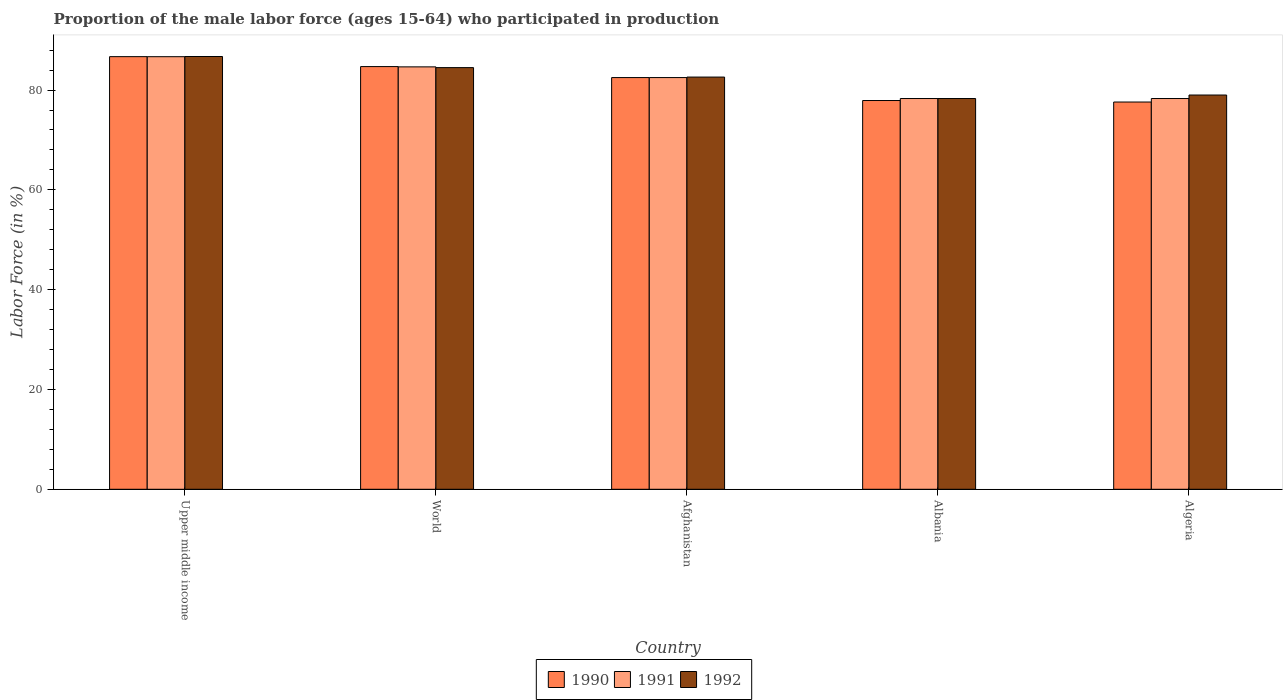How many groups of bars are there?
Your response must be concise. 5. Are the number of bars per tick equal to the number of legend labels?
Your answer should be compact. Yes. How many bars are there on the 4th tick from the left?
Your answer should be very brief. 3. How many bars are there on the 1st tick from the right?
Make the answer very short. 3. What is the label of the 5th group of bars from the left?
Offer a very short reply. Algeria. What is the proportion of the male labor force who participated in production in 1991 in Afghanistan?
Your answer should be very brief. 82.5. Across all countries, what is the maximum proportion of the male labor force who participated in production in 1992?
Keep it short and to the point. 86.72. Across all countries, what is the minimum proportion of the male labor force who participated in production in 1990?
Offer a very short reply. 77.6. In which country was the proportion of the male labor force who participated in production in 1990 maximum?
Ensure brevity in your answer.  Upper middle income. In which country was the proportion of the male labor force who participated in production in 1990 minimum?
Ensure brevity in your answer.  Algeria. What is the total proportion of the male labor force who participated in production in 1990 in the graph?
Offer a very short reply. 409.39. What is the difference between the proportion of the male labor force who participated in production in 1992 in Afghanistan and that in World?
Keep it short and to the point. -1.89. What is the difference between the proportion of the male labor force who participated in production in 1992 in World and the proportion of the male labor force who participated in production in 1991 in Algeria?
Provide a short and direct response. 6.19. What is the average proportion of the male labor force who participated in production in 1990 per country?
Make the answer very short. 81.88. What is the difference between the proportion of the male labor force who participated in production of/in 1990 and proportion of the male labor force who participated in production of/in 1992 in World?
Offer a terse response. 0.2. What is the ratio of the proportion of the male labor force who participated in production in 1991 in Afghanistan to that in Algeria?
Offer a terse response. 1.05. Is the proportion of the male labor force who participated in production in 1992 in Albania less than that in Algeria?
Your answer should be very brief. Yes. Is the difference between the proportion of the male labor force who participated in production in 1990 in Albania and World greater than the difference between the proportion of the male labor force who participated in production in 1992 in Albania and World?
Offer a very short reply. No. What is the difference between the highest and the second highest proportion of the male labor force who participated in production in 1990?
Your answer should be very brief. -2.2. What is the difference between the highest and the lowest proportion of the male labor force who participated in production in 1990?
Offer a terse response. 9.09. What does the 1st bar from the left in Afghanistan represents?
Your answer should be compact. 1990. What does the 1st bar from the right in Upper middle income represents?
Ensure brevity in your answer.  1992. How many bars are there?
Keep it short and to the point. 15. Are all the bars in the graph horizontal?
Ensure brevity in your answer.  No. Are the values on the major ticks of Y-axis written in scientific E-notation?
Your response must be concise. No. Does the graph contain any zero values?
Keep it short and to the point. No. How many legend labels are there?
Your response must be concise. 3. How are the legend labels stacked?
Make the answer very short. Horizontal. What is the title of the graph?
Provide a succinct answer. Proportion of the male labor force (ages 15-64) who participated in production. Does "1998" appear as one of the legend labels in the graph?
Your answer should be very brief. No. What is the Labor Force (in %) of 1990 in Upper middle income?
Give a very brief answer. 86.69. What is the Labor Force (in %) of 1991 in Upper middle income?
Give a very brief answer. 86.68. What is the Labor Force (in %) in 1992 in Upper middle income?
Ensure brevity in your answer.  86.72. What is the Labor Force (in %) in 1990 in World?
Your answer should be compact. 84.7. What is the Labor Force (in %) of 1991 in World?
Offer a terse response. 84.64. What is the Labor Force (in %) in 1992 in World?
Your answer should be very brief. 84.49. What is the Labor Force (in %) of 1990 in Afghanistan?
Your answer should be compact. 82.5. What is the Labor Force (in %) of 1991 in Afghanistan?
Your response must be concise. 82.5. What is the Labor Force (in %) of 1992 in Afghanistan?
Make the answer very short. 82.6. What is the Labor Force (in %) of 1990 in Albania?
Offer a terse response. 77.9. What is the Labor Force (in %) of 1991 in Albania?
Offer a terse response. 78.3. What is the Labor Force (in %) of 1992 in Albania?
Offer a terse response. 78.3. What is the Labor Force (in %) of 1990 in Algeria?
Your answer should be very brief. 77.6. What is the Labor Force (in %) of 1991 in Algeria?
Keep it short and to the point. 78.3. What is the Labor Force (in %) of 1992 in Algeria?
Your response must be concise. 79. Across all countries, what is the maximum Labor Force (in %) in 1990?
Make the answer very short. 86.69. Across all countries, what is the maximum Labor Force (in %) of 1991?
Offer a terse response. 86.68. Across all countries, what is the maximum Labor Force (in %) in 1992?
Ensure brevity in your answer.  86.72. Across all countries, what is the minimum Labor Force (in %) in 1990?
Offer a terse response. 77.6. Across all countries, what is the minimum Labor Force (in %) of 1991?
Provide a short and direct response. 78.3. Across all countries, what is the minimum Labor Force (in %) in 1992?
Make the answer very short. 78.3. What is the total Labor Force (in %) of 1990 in the graph?
Ensure brevity in your answer.  409.39. What is the total Labor Force (in %) of 1991 in the graph?
Provide a short and direct response. 410.42. What is the total Labor Force (in %) in 1992 in the graph?
Offer a terse response. 411.11. What is the difference between the Labor Force (in %) of 1990 in Upper middle income and that in World?
Keep it short and to the point. 1.99. What is the difference between the Labor Force (in %) of 1991 in Upper middle income and that in World?
Your response must be concise. 2.04. What is the difference between the Labor Force (in %) of 1992 in Upper middle income and that in World?
Your response must be concise. 2.22. What is the difference between the Labor Force (in %) in 1990 in Upper middle income and that in Afghanistan?
Provide a short and direct response. 4.19. What is the difference between the Labor Force (in %) of 1991 in Upper middle income and that in Afghanistan?
Provide a succinct answer. 4.18. What is the difference between the Labor Force (in %) of 1992 in Upper middle income and that in Afghanistan?
Offer a terse response. 4.12. What is the difference between the Labor Force (in %) in 1990 in Upper middle income and that in Albania?
Ensure brevity in your answer.  8.79. What is the difference between the Labor Force (in %) of 1991 in Upper middle income and that in Albania?
Keep it short and to the point. 8.38. What is the difference between the Labor Force (in %) in 1992 in Upper middle income and that in Albania?
Offer a terse response. 8.42. What is the difference between the Labor Force (in %) of 1990 in Upper middle income and that in Algeria?
Provide a succinct answer. 9.09. What is the difference between the Labor Force (in %) in 1991 in Upper middle income and that in Algeria?
Your response must be concise. 8.38. What is the difference between the Labor Force (in %) of 1992 in Upper middle income and that in Algeria?
Your response must be concise. 7.72. What is the difference between the Labor Force (in %) in 1990 in World and that in Afghanistan?
Make the answer very short. 2.2. What is the difference between the Labor Force (in %) of 1991 in World and that in Afghanistan?
Ensure brevity in your answer.  2.14. What is the difference between the Labor Force (in %) of 1992 in World and that in Afghanistan?
Keep it short and to the point. 1.89. What is the difference between the Labor Force (in %) of 1990 in World and that in Albania?
Ensure brevity in your answer.  6.8. What is the difference between the Labor Force (in %) in 1991 in World and that in Albania?
Provide a succinct answer. 6.34. What is the difference between the Labor Force (in %) of 1992 in World and that in Albania?
Ensure brevity in your answer.  6.19. What is the difference between the Labor Force (in %) of 1990 in World and that in Algeria?
Make the answer very short. 7.1. What is the difference between the Labor Force (in %) of 1991 in World and that in Algeria?
Give a very brief answer. 6.34. What is the difference between the Labor Force (in %) in 1992 in World and that in Algeria?
Your answer should be compact. 5.49. What is the difference between the Labor Force (in %) in 1992 in Albania and that in Algeria?
Your answer should be very brief. -0.7. What is the difference between the Labor Force (in %) of 1990 in Upper middle income and the Labor Force (in %) of 1991 in World?
Give a very brief answer. 2.05. What is the difference between the Labor Force (in %) of 1990 in Upper middle income and the Labor Force (in %) of 1992 in World?
Your answer should be compact. 2.2. What is the difference between the Labor Force (in %) of 1991 in Upper middle income and the Labor Force (in %) of 1992 in World?
Your answer should be compact. 2.19. What is the difference between the Labor Force (in %) in 1990 in Upper middle income and the Labor Force (in %) in 1991 in Afghanistan?
Offer a very short reply. 4.19. What is the difference between the Labor Force (in %) of 1990 in Upper middle income and the Labor Force (in %) of 1992 in Afghanistan?
Your answer should be compact. 4.09. What is the difference between the Labor Force (in %) in 1991 in Upper middle income and the Labor Force (in %) in 1992 in Afghanistan?
Provide a succinct answer. 4.08. What is the difference between the Labor Force (in %) of 1990 in Upper middle income and the Labor Force (in %) of 1991 in Albania?
Your answer should be very brief. 8.39. What is the difference between the Labor Force (in %) in 1990 in Upper middle income and the Labor Force (in %) in 1992 in Albania?
Your answer should be very brief. 8.39. What is the difference between the Labor Force (in %) in 1991 in Upper middle income and the Labor Force (in %) in 1992 in Albania?
Make the answer very short. 8.38. What is the difference between the Labor Force (in %) of 1990 in Upper middle income and the Labor Force (in %) of 1991 in Algeria?
Offer a very short reply. 8.39. What is the difference between the Labor Force (in %) in 1990 in Upper middle income and the Labor Force (in %) in 1992 in Algeria?
Make the answer very short. 7.69. What is the difference between the Labor Force (in %) of 1991 in Upper middle income and the Labor Force (in %) of 1992 in Algeria?
Provide a short and direct response. 7.68. What is the difference between the Labor Force (in %) in 1990 in World and the Labor Force (in %) in 1991 in Afghanistan?
Your answer should be very brief. 2.2. What is the difference between the Labor Force (in %) in 1990 in World and the Labor Force (in %) in 1992 in Afghanistan?
Your answer should be very brief. 2.1. What is the difference between the Labor Force (in %) in 1991 in World and the Labor Force (in %) in 1992 in Afghanistan?
Your answer should be very brief. 2.04. What is the difference between the Labor Force (in %) of 1990 in World and the Labor Force (in %) of 1991 in Albania?
Provide a succinct answer. 6.4. What is the difference between the Labor Force (in %) of 1990 in World and the Labor Force (in %) of 1992 in Albania?
Give a very brief answer. 6.4. What is the difference between the Labor Force (in %) in 1991 in World and the Labor Force (in %) in 1992 in Albania?
Offer a very short reply. 6.34. What is the difference between the Labor Force (in %) in 1990 in World and the Labor Force (in %) in 1991 in Algeria?
Your response must be concise. 6.4. What is the difference between the Labor Force (in %) of 1990 in World and the Labor Force (in %) of 1992 in Algeria?
Offer a terse response. 5.7. What is the difference between the Labor Force (in %) in 1991 in World and the Labor Force (in %) in 1992 in Algeria?
Keep it short and to the point. 5.64. What is the difference between the Labor Force (in %) of 1990 in Afghanistan and the Labor Force (in %) of 1991 in Albania?
Give a very brief answer. 4.2. What is the difference between the Labor Force (in %) in 1990 in Afghanistan and the Labor Force (in %) in 1992 in Albania?
Your answer should be very brief. 4.2. What is the difference between the Labor Force (in %) in 1991 in Afghanistan and the Labor Force (in %) in 1992 in Algeria?
Your answer should be compact. 3.5. What is the difference between the Labor Force (in %) of 1990 in Albania and the Labor Force (in %) of 1991 in Algeria?
Keep it short and to the point. -0.4. What is the difference between the Labor Force (in %) of 1990 in Albania and the Labor Force (in %) of 1992 in Algeria?
Your answer should be very brief. -1.1. What is the average Labor Force (in %) of 1990 per country?
Ensure brevity in your answer.  81.88. What is the average Labor Force (in %) of 1991 per country?
Your answer should be very brief. 82.08. What is the average Labor Force (in %) of 1992 per country?
Provide a succinct answer. 82.22. What is the difference between the Labor Force (in %) in 1990 and Labor Force (in %) in 1991 in Upper middle income?
Provide a short and direct response. 0.01. What is the difference between the Labor Force (in %) in 1990 and Labor Force (in %) in 1992 in Upper middle income?
Provide a succinct answer. -0.03. What is the difference between the Labor Force (in %) of 1991 and Labor Force (in %) of 1992 in Upper middle income?
Your answer should be compact. -0.04. What is the difference between the Labor Force (in %) in 1990 and Labor Force (in %) in 1991 in World?
Give a very brief answer. 0.06. What is the difference between the Labor Force (in %) in 1990 and Labor Force (in %) in 1992 in World?
Your answer should be compact. 0.2. What is the difference between the Labor Force (in %) in 1991 and Labor Force (in %) in 1992 in World?
Ensure brevity in your answer.  0.15. What is the difference between the Labor Force (in %) of 1990 and Labor Force (in %) of 1991 in Afghanistan?
Ensure brevity in your answer.  0. What is the difference between the Labor Force (in %) in 1991 and Labor Force (in %) in 1992 in Afghanistan?
Ensure brevity in your answer.  -0.1. What is the difference between the Labor Force (in %) of 1990 and Labor Force (in %) of 1992 in Albania?
Provide a succinct answer. -0.4. What is the difference between the Labor Force (in %) in 1990 and Labor Force (in %) in 1991 in Algeria?
Your answer should be compact. -0.7. What is the difference between the Labor Force (in %) of 1990 and Labor Force (in %) of 1992 in Algeria?
Keep it short and to the point. -1.4. What is the difference between the Labor Force (in %) of 1991 and Labor Force (in %) of 1992 in Algeria?
Your answer should be very brief. -0.7. What is the ratio of the Labor Force (in %) of 1990 in Upper middle income to that in World?
Your response must be concise. 1.02. What is the ratio of the Labor Force (in %) in 1991 in Upper middle income to that in World?
Offer a very short reply. 1.02. What is the ratio of the Labor Force (in %) of 1992 in Upper middle income to that in World?
Offer a terse response. 1.03. What is the ratio of the Labor Force (in %) in 1990 in Upper middle income to that in Afghanistan?
Your answer should be compact. 1.05. What is the ratio of the Labor Force (in %) in 1991 in Upper middle income to that in Afghanistan?
Make the answer very short. 1.05. What is the ratio of the Labor Force (in %) in 1992 in Upper middle income to that in Afghanistan?
Provide a short and direct response. 1.05. What is the ratio of the Labor Force (in %) in 1990 in Upper middle income to that in Albania?
Your response must be concise. 1.11. What is the ratio of the Labor Force (in %) in 1991 in Upper middle income to that in Albania?
Provide a succinct answer. 1.11. What is the ratio of the Labor Force (in %) of 1992 in Upper middle income to that in Albania?
Keep it short and to the point. 1.11. What is the ratio of the Labor Force (in %) in 1990 in Upper middle income to that in Algeria?
Make the answer very short. 1.12. What is the ratio of the Labor Force (in %) of 1991 in Upper middle income to that in Algeria?
Offer a terse response. 1.11. What is the ratio of the Labor Force (in %) in 1992 in Upper middle income to that in Algeria?
Your response must be concise. 1.1. What is the ratio of the Labor Force (in %) of 1990 in World to that in Afghanistan?
Provide a succinct answer. 1.03. What is the ratio of the Labor Force (in %) in 1992 in World to that in Afghanistan?
Keep it short and to the point. 1.02. What is the ratio of the Labor Force (in %) in 1990 in World to that in Albania?
Give a very brief answer. 1.09. What is the ratio of the Labor Force (in %) of 1991 in World to that in Albania?
Your answer should be very brief. 1.08. What is the ratio of the Labor Force (in %) of 1992 in World to that in Albania?
Your answer should be compact. 1.08. What is the ratio of the Labor Force (in %) in 1990 in World to that in Algeria?
Keep it short and to the point. 1.09. What is the ratio of the Labor Force (in %) in 1991 in World to that in Algeria?
Your answer should be very brief. 1.08. What is the ratio of the Labor Force (in %) in 1992 in World to that in Algeria?
Ensure brevity in your answer.  1.07. What is the ratio of the Labor Force (in %) in 1990 in Afghanistan to that in Albania?
Provide a short and direct response. 1.06. What is the ratio of the Labor Force (in %) in 1991 in Afghanistan to that in Albania?
Offer a terse response. 1.05. What is the ratio of the Labor Force (in %) of 1992 in Afghanistan to that in Albania?
Your answer should be compact. 1.05. What is the ratio of the Labor Force (in %) in 1990 in Afghanistan to that in Algeria?
Give a very brief answer. 1.06. What is the ratio of the Labor Force (in %) in 1991 in Afghanistan to that in Algeria?
Keep it short and to the point. 1.05. What is the ratio of the Labor Force (in %) in 1992 in Afghanistan to that in Algeria?
Provide a succinct answer. 1.05. What is the ratio of the Labor Force (in %) of 1991 in Albania to that in Algeria?
Make the answer very short. 1. What is the difference between the highest and the second highest Labor Force (in %) of 1990?
Your response must be concise. 1.99. What is the difference between the highest and the second highest Labor Force (in %) in 1991?
Keep it short and to the point. 2.04. What is the difference between the highest and the second highest Labor Force (in %) in 1992?
Your answer should be very brief. 2.22. What is the difference between the highest and the lowest Labor Force (in %) of 1990?
Your answer should be very brief. 9.09. What is the difference between the highest and the lowest Labor Force (in %) in 1991?
Keep it short and to the point. 8.38. What is the difference between the highest and the lowest Labor Force (in %) in 1992?
Offer a very short reply. 8.42. 